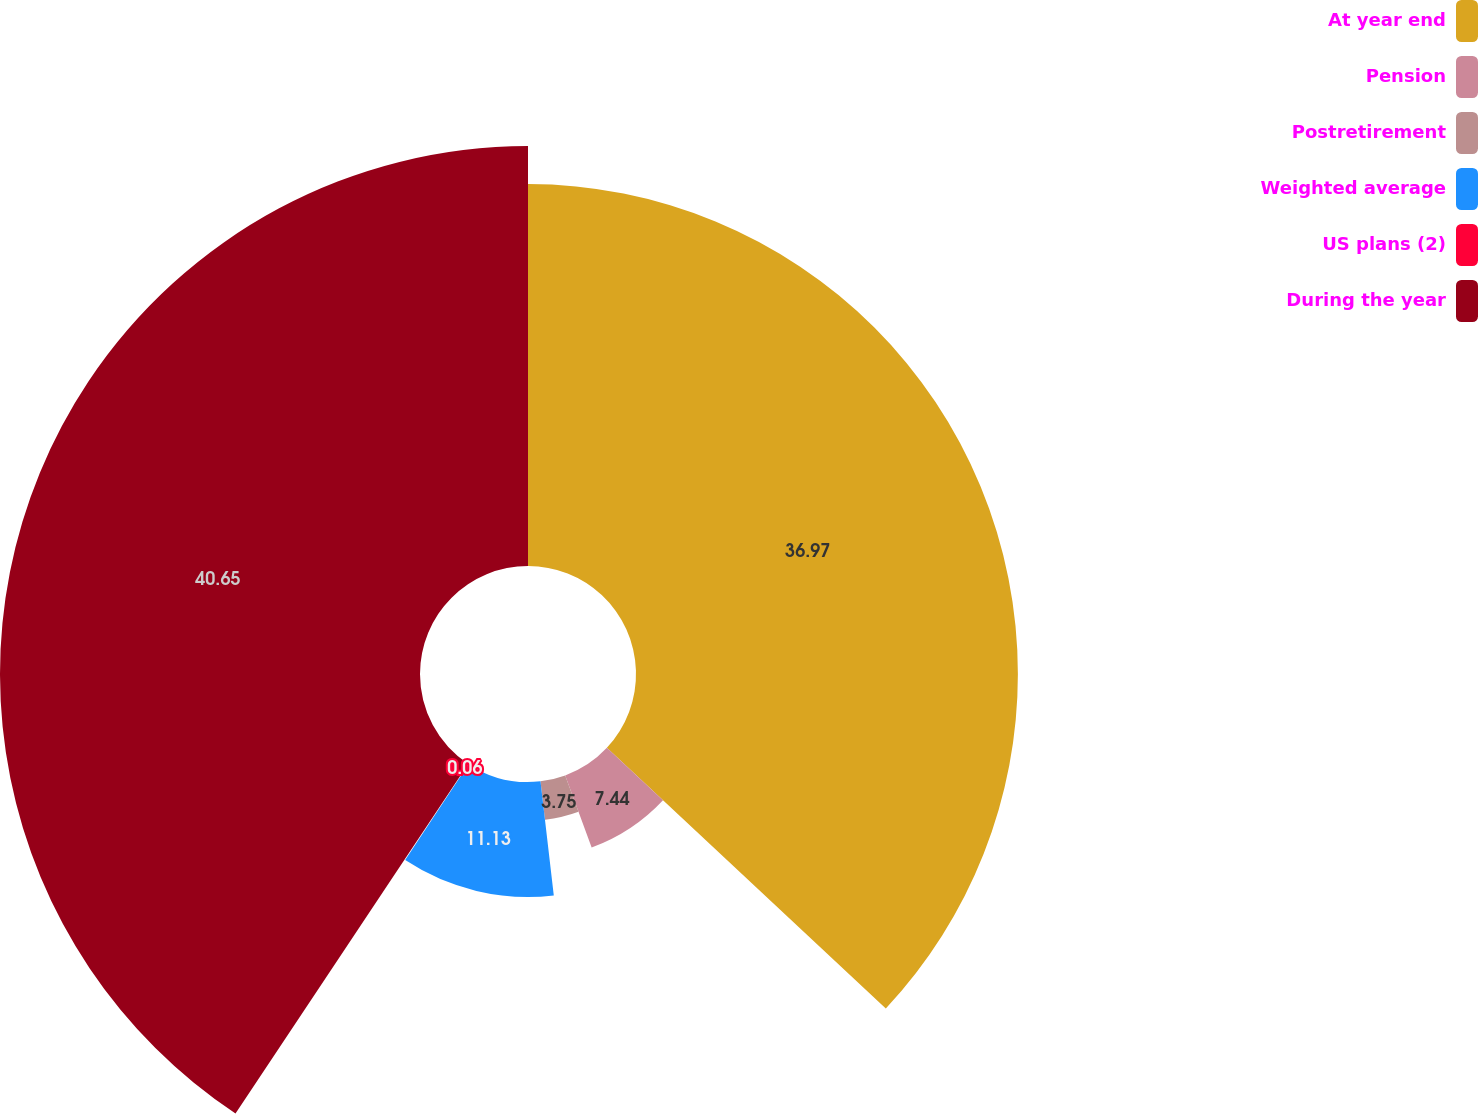Convert chart. <chart><loc_0><loc_0><loc_500><loc_500><pie_chart><fcel>At year end<fcel>Pension<fcel>Postretirement<fcel>Weighted average<fcel>US plans (2)<fcel>During the year<nl><fcel>36.97%<fcel>7.44%<fcel>3.75%<fcel>11.13%<fcel>0.06%<fcel>40.66%<nl></chart> 